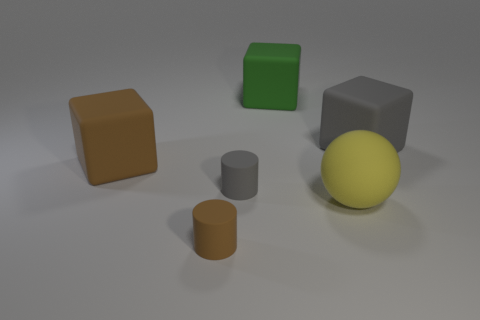Subtract all gray cylinders. How many cylinders are left? 1 Subtract all balls. How many objects are left? 5 Add 1 small purple objects. How many objects exist? 7 Add 4 tiny brown metallic things. How many tiny brown metallic things exist? 4 Subtract 1 brown blocks. How many objects are left? 5 Subtract 1 cylinders. How many cylinders are left? 1 Subtract all blue blocks. Subtract all yellow cylinders. How many blocks are left? 3 Subtract all blue cylinders. How many brown cubes are left? 1 Subtract all large green shiny cubes. Subtract all large brown objects. How many objects are left? 5 Add 1 brown things. How many brown things are left? 3 